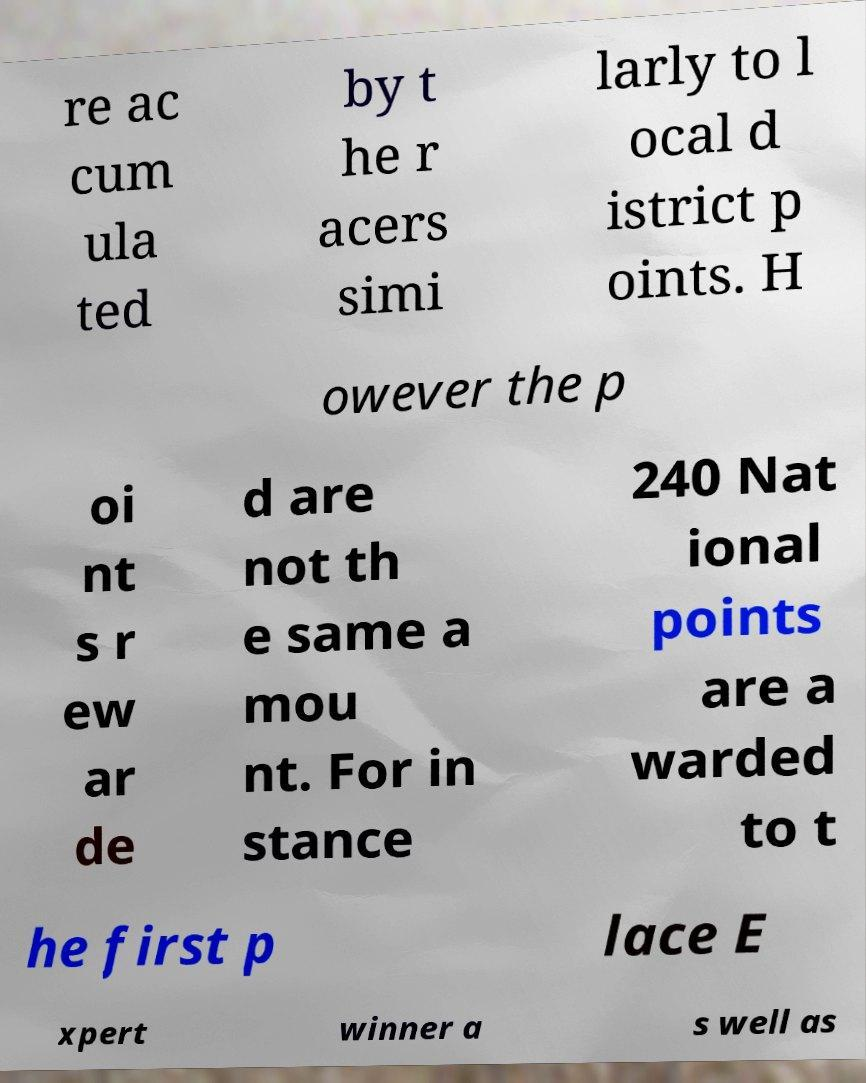Can you accurately transcribe the text from the provided image for me? re ac cum ula ted by t he r acers simi larly to l ocal d istrict p oints. H owever the p oi nt s r ew ar de d are not th e same a mou nt. For in stance 240 Nat ional points are a warded to t he first p lace E xpert winner a s well as 